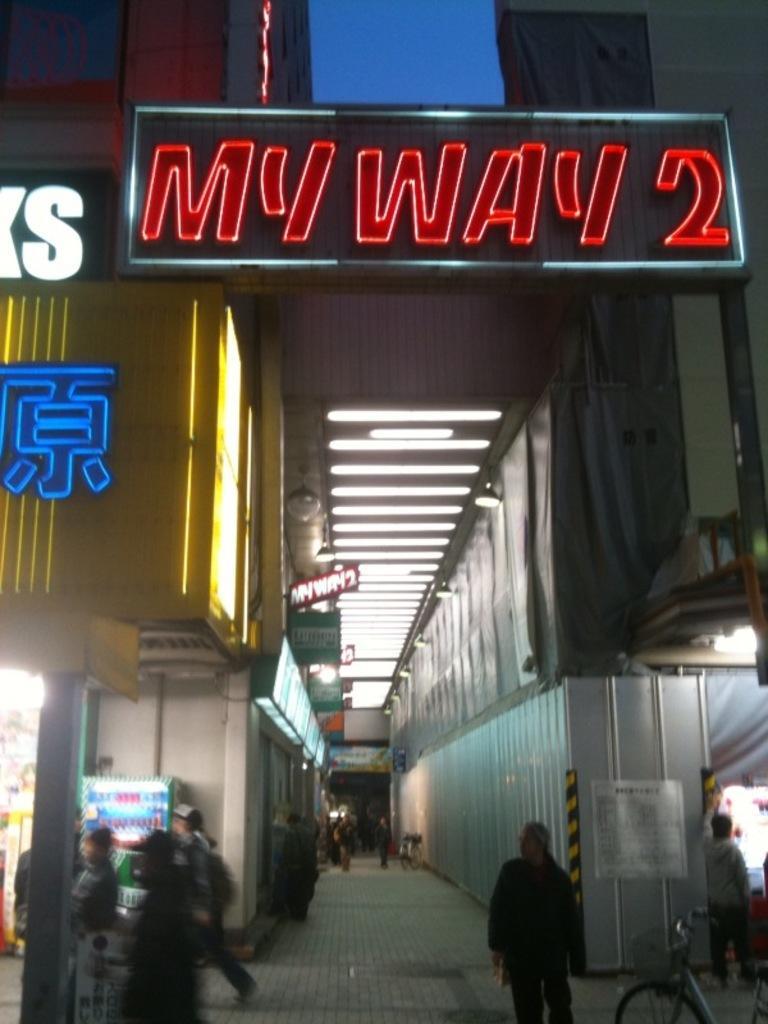In one or two sentences, can you explain what this image depicts? In this image we can see a group of people standing on the ground and a bicycle parked aside. We can also see the buildings with sign boards and some text on it, some boards, ceiling lights to a roof, a container and a paper pasted on a wall. 